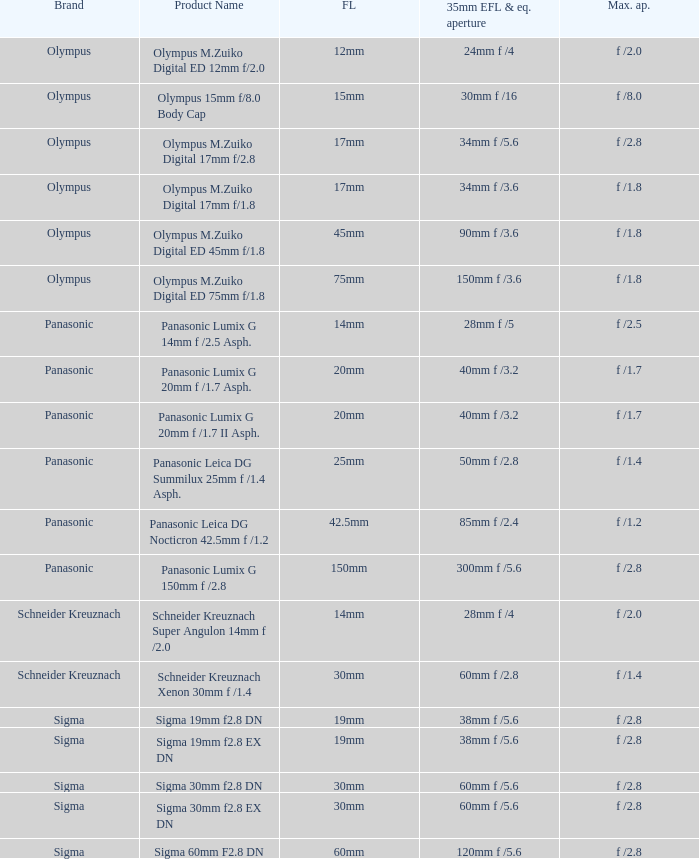What is the 35mm EFL and the equivalent aperture of the lens(es) with a maximum aperture of f /2.5? 28mm f /5. 